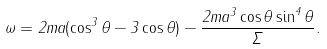<formula> <loc_0><loc_0><loc_500><loc_500>\omega = 2 m a ( \cos ^ { 3 } \theta - 3 \cos \theta ) - \frac { 2 m a ^ { 3 } \cos \theta \sin ^ { 4 } \theta } { \Sigma } .</formula> 